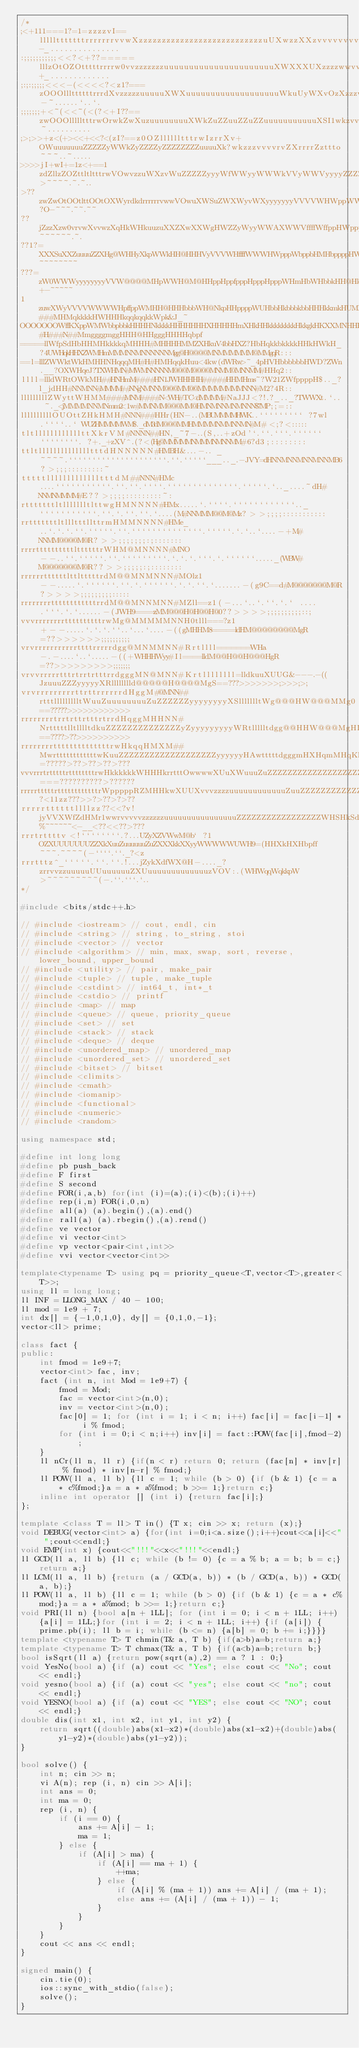<code> <loc_0><loc_0><loc_500><loc_500><_C++_>/*
;<+111===1?=1=zzzzvI==llllltttttttrrrrrrrvvwXzzzzzzzzzzzzzzzzzzzzzzzzzzzuUXwzzXXzvvvvvvvvXXwrrrrrrrrttz-_...............
:;;;;;;;;;;;<<?<+??=====lllzOtOZOtttttrrrrw0vvzzzzzzzuuuuuuuuuuuuuuuuuuuuuuXWXXXUXzzzzwwvvvwUwvvrrrrrrttt+_.............
;:;:;;;;;<<<-(<<<<?<z1?===zOOOlllttttttrrrdXvzzzzzuuuuuXWXuuuuuuuuuuuuuuuuuuuWkuUyWXvOzXzzzvvzXwvrrrrrrrttO-~......`..`.
;;;;;;;+<~(<<~(<(?<+I??==zwOOOllllltttrwOrwkZwXuzuuuuuuuuXWkZuZZuuZZuZZuuuuuuuuuuuXSI1wkzvvvvvvwXwvrrrrrtttO_~..........
;>;>>+z<(+><<+<<?<(zI?==z0OZlllllltttrwIzrrXv+OWuuuuuuuZZZZZyWWkZyZZZZyZZZZZZZZuuuuXk?wkzzzvvvvrvZXrrrrZzttto~~~..~.....
>>>>jI+wI+=1z<+==1zdZllzZOZttltltttrwVOwvzzuWXzvWuZZZZZyyyWfWWyyWWWkVVyWWVyyyyZZZZZX0zXkuuzzvvvvrrrrrrtrzdO1z>~~~~.~.~..
>??zwZwOtOOtlttOOtOXWyrdkdrrrrrrvwwVOwuXWSuZWXWyvWXyyyyyyyVVVVWHWppWWkkWkWHWVyyyyyyXkXWWkXuuuzzvvvvrrrzzOzXy?O-~~~.~~.~~
??jZzzXzw0vrvwXvvwzXqHkWHkuuzuXXZXwXXWgHWZZyWyyWWAXWWVffffWffppHWppppppppppHkpffffWWWHyyHHXZZZuXXuuuuuzOOwwZkzI~~~~~~.~.
??1?=XXXSuXXZuuuuZZXHg@WHHyXkpWWkHH@HHHVyVVVWHffffWWWHWpppWbppbHMHbppppHWpbpbHWbpWHHpHWpW@NkWHWykXWXyZyZkwwXyXWc~~~~~~~~
???=zW0WWWyyyyyyyyVVW@@@@MHpWWH@M@HHppHppfpppHpppHpppWHmHbWHbbkHH@HkbbkbHHkkkkHHkkkkkHNkHHHNWHHpppkWHWpppppkXpffk+-~~~~~
1zuwXWyVVVVWWWWHpffppWMHH@HHHbbbWH@NkpHHppppWUHbbHkbbbkbbHHHkkmkHUMMHkkkqMMHqkkkHHqqqMMqM###MHMqkkkkHWHHHkqqkqqkkWpk&J_~
OOOOOOOWffKXppWMWbbpbbkHHHHNkkkkHHHHHHHXHHHHHmXHkHHkkkkkkkkHkkgkHKXXMNHHHHHWMNHgHHHHHM#H###N##MmggggmggHHH@HHgggHHHHqbpf
=====llWfpSdHbHHMHkkkkqMHHH#MHHHHMMZXHkuV4bbHXZ?HbHqkkbkkkkHHkHWkH_?4UWHqkHHXZWMHmMMMNNMNNNNNNMgg@H@@@@MNMMMMMM@MMgqR:::
==l=lllZWWktWkHMHHNHqqqMH#H#HMHqqkHuu<4kw(dWRw>~_4pHVHbbbbbbHWD?ZWn.__?OXWHqeJ?TXWHMN#MWMNNNNNM@@@M@@@@MNMM@MNNMM#HHq2::
llll=llldWRtOWkMH##HNHmM####HN1JWHHHHH#####HHMHms~?W21ZWfppppH$.._?l_jdHH#NNMNN#MMMM##NNgNMNNM@@@MM@@MMMMMMMMNNN#M2?4R::
lllllllllZWyttWHMM####MNM####N<WH#TC<dMMMM#NaJJJ<?!.?_.._?TWWXt.`.. ~._<jMMMMNNMNmm2<1w#MMNMM@@@MM@HMNMNNMNMNNN$7MP;;=::
llllllllllOUOttZHkHMH#NNN###HHr(HN-..(MBUMMMMHWK..````````` ?7wl.````..` WUZHMMMMWM$._dM3dM@@@MMHMMMMNMMNNMN#M#<;?<:::::
tltllllllllllllttXkrVM#NNNN##HN,_~7-..(S,..+zOd'`.``.```.`````` ````````. ?+._+zXV^.(?<(Hg@MMMMMNMMMNMNNMM#6?d3;::::::::
ttltlllllllllllllltttdHNNNNN#HMBH&...-.. _~~~~.`````````````````````.``.`````___.._.-JVY=dHNNMNNMNNMNNMB6?>;;;:::::::::~
tttttllllllllllllltttdM##NNN#HMc....```````````.``.``.````.``````````````.`````.`.._....~dH#NNMNMMMM#E??>;;;;:::::::::~:
rtttttttltllllllltlttwgHMNNNN#HMx.....`.````.````````````.._```````````.``.`.``.``.`....(M#NNMMM@@M@Mz?>>;;;;:::::::::::
rrtttttttltllltttllttrmHMMNNNN#HMe_..`.`.`.``.`````.``.``````````````.`````.`.`..`....-+M#NNMM@@@@M@R?>>;;;;;;;:;:::::::
rrrrttttttttttlttttttrWHM@MNNNN#MNO--..``.`````.``.`````````.`.`.`.```.`.``````....._(WBW#M@@@@@@@M@R??>>;;;;;:;::::::::
rrrrrrttttttlttltttttrdM@@MNMNNN#MOlz1--.....`.``````.``.`.``````.`.`.``.`.......-(g9C==d#M@@@@@@@M@R?>>>>;;;;;;;;;:::::
rrrrrrrrttttttttttttrrdM@@MNNMNN#MZll==z1(-...`..`.``.`.` .... .```.`.`......-(JWH9====zMM@@@H@H@@H@0??>>>>;;;;;;;;;;::;
vvvrrrrrrrrttttttttttrwMg@MMMMMNNH0tlll===?z1+--.....`.`.`.``..`...`....-((gMHHM8=====ldHM@@@@@@@@MgR=??>>>>>>;;;;;;;;;;
vrvrrrrrrrrrrrttttrrrrrdgg@MNMMNN#Rrtllll=======WHa-.-....`..`.....-((+WHHHWyy#Il====lldM@@H@@H@@@HgR=??>>>>>>>>>;;;;;;;
vrvvrrrrrtttrtrrtrtttrrdgggMN@MNN#Krtllllllll=lldkuuXUUG&---.-((JzuuuZZZyyyyyXRlllllllld@@@@@H@@@@MgS==???>>>>>>>;>>>;>;
vrvrrrrrrrrrttrttrrrrrrdHggM#@MNN##rtttllllllllltWuuZuuuuuuuuZuZZZZZZyyyyyyyyXSllllllltWg@@@HW@@@MMg0==?????>>>>>>>>>>>>
rrrrrrrrtrrtrttrtttrtrrdHqggMHHNN#NrtttttlltlllltdkuZZZZZZZZZZZZZZyZyyyyyyyyyWRtllllltdgg@@HHW@@@MgHI==????>??>>>>>>>>>>
rrrrrrrrttttttttttttttrwHkqqHMXM##MwrttttttttttttwKuuZZZZZZZZZZZZZZZZZZZyyyyyyHAwtttttdgggmHXHqmMHqKl=?????>??>??>??>???
vvvrrrtrtttttrttttttttrwHkkkkkkWHHHkrrtttOwwwwXUuXWuuuZuZZZZZZZZZZZZZZZZZZZZyyyyyyWWyqHHHkHZdXWHMkHS===??????????>??????
rrrrrtttttrttttttttttttrWpppppRZMHHkwXUUXvvvzzzzuuuuuuuuuuuuZuuZZZZZZZZZZZZZZZZZZZZZXHHHkH0wXSXHppW7?<11zz???>>?>??>?>??
rrrrrttttttllllzz??<<?v!jyVVXWfZdHMr1wwrvvvvvzzzzzzuuuuuuuuuuuuuuuuZZZZZZZZZZZZZZZZZWHSHkSdSXdWffV%~~~~~~<-__<??<<??>???
rrrtrttttv<!````````.?...UZyXZVWwM@b` ?1OZXUUUUUUUZZXkXuuZuuuuuuZuZXXXkkXXyyWWWWWUWH9=(HHXkHXHbpff~~~.~~~~(-````.``._?<z
rrrtttz^_`````.``.``.!...jZykXdfWX@H-...._?zrrvvzzuuuuuUUuuuuuuZXUuuuuuuuuuuuuuzVOV:.(WHWqqWqkkpW>~~~~~~~~~(-.``.```.`..
*/

#include <bits/stdc++.h>

// #include <iostream> // cout, endl, cin
// #include <string> // string, to_string, stoi
// #include <vector> // vector
// #include <algorithm> // min, max, swap, sort, reverse, lower_bound, upper_bound
// #include <utility> // pair, make_pair
// #include <tuple> // tuple, make_tuple
// #include <cstdint> // int64_t, int*_t
// #include <cstdio> // printf
// #include <map> // map
// #include <queue> // queue, priority_queue
// #include <set> // set
// #include <stack> // stack
// #include <deque> // deque
// #include <unordered_map> // unordered_map
// #include <unordered_set> // unordered_set
// #include <bitset> // bitset
// #include <climits>
// #include <cmath>
// #include <iomanip>
// #include <functional>
// #include <numeric>
// #include <random>

using namespace std;
    
#define int long long
#define pb push_back
#define F first
#define S second
#define FOR(i,a,b) for(int (i)=(a);(i)<(b);(i)++)
#define rep(i,n) FOR(i,0,n)
#define all(a) (a).begin(),(a).end()
#define rall(a) (a).rbegin(),(a).rend()
#define ve vector
#define vi vector<int>
#define vp vector<pair<int,int>>
#define vvi vector<vector<int>>

template<typename T> using pq = priority_queue<T,vector<T>,greater<T>>; 
using ll = long long;
ll INF = LLONG_MAX / 40 - 100;
ll mod = 1e9 + 7;
int dx[] = {-1,0,1,0}, dy[] = {0,1,0,-1};
vector<ll> prime;
    
class fact {
public:
    int fmod = 1e9+7;
    vector<int> fac, inv;
    fact (int n, int Mod = 1e9+7) {
        fmod = Mod;
        fac = vector<int>(n,0);
        inv = vector<int>(n,0);
        fac[0] = 1; for (int i = 1; i < n; i++) fac[i] = fac[i-1] * i % fmod;
        for (int i = 0;i < n;i++) inv[i] = fact::POW(fac[i],fmod-2);
    }
    ll nCr(ll n, ll r) {if(n < r) return 0; return (fac[n] * inv[r] % fmod) * inv[n-r] % fmod;}
    ll POW(ll a, ll b) {ll c = 1; while (b > 0) {if (b & 1) {c = a * c%fmod;}a = a * a%fmod; b >>= 1;}return c;}
    inline int operator [] (int i) {return fac[i];}
};
    
template <class T = ll> T in() {T x; cin >> x; return (x);}
void DEBUG(vector<int> a) {for(int i=0;i<a.size();i++)cout<<a[i]<<" ";cout<<endl;}
void EMP(int x) {cout<<"!!!"<<x<<"!!!"<<endl;}
ll GCD(ll a, ll b) {ll c; while (b != 0) {c = a % b; a = b; b = c;}return a;}
ll LCM(ll a, ll b) {return (a / GCD(a, b)) * (b / GCD(a, b)) * GCD(a, b);}
ll POW(ll a, ll b) {ll c = 1; while (b > 0) {if (b & 1) {c = a * c%mod;}a = a * a%mod; b >>= 1;}return c;}
void PRI(ll n) {bool a[n + 1LL]; for (int i = 0; i < n + 1LL; i++) {a[i] = 1LL;}for (int i = 2; i < n + 1LL; i++) {if (a[i]) {prime.pb(i); ll b = i; while (b <= n) {a[b] = 0; b += i;}}}}
template <typename T> T chmin(T& a, T b) {if(a>b)a=b;return a;}
template <typename T> T chmax(T& a, T b) {if(a<b)a=b;return b;}
bool isSqrt(ll a) {return pow(sqrt(a),2) == a ? 1 : 0;}
void YesNo(bool a) {if (a) cout << "Yes"; else cout << "No"; cout << endl;}
void yesno(bool a) {if (a) cout << "yes"; else cout << "no"; cout << endl;}
void YESNO(bool a) {if (a) cout << "YES"; else cout << "NO"; cout << endl;}
double dis(int x1, int x2, int y1, int y2) {
    return sqrt((double)abs(x1-x2)*(double)abs(x1-x2)+(double)abs(y1-y2)*(double)abs(y1-y2));
}

bool solve() {
    int n; cin >> n;
    vi A(n); rep (i, n) cin >> A[i];
    int ans = 0;
    int ma = 0;
    rep (i, n) {
        if (i == 0) {
            ans += A[i] - 1;
            ma = 1;
        } else {
            if (A[i] > ma) {
                if (A[i] == ma + 1) {
                    ++ma;
                } else {
                    if (A[i] % (ma + 1)) ans += A[i] / (ma + 1);
                    else ans += (A[i] / (ma + 1)) - 1;
                }
            }
        }
    }
    cout << ans << endl;
}

signed main() {
    cin.tie(0);
    ios::sync_with_stdio(false);
    solve();
}
</code> 